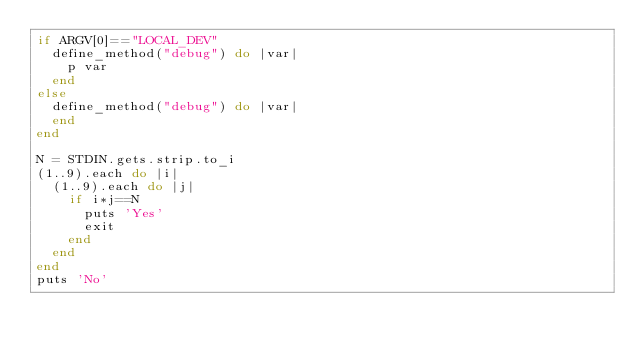<code> <loc_0><loc_0><loc_500><loc_500><_Ruby_>if ARGV[0]=="LOCAL_DEV"
  define_method("debug") do |var|
    p var
  end
else
  define_method("debug") do |var|
  end
end

N = STDIN.gets.strip.to_i
(1..9).each do |i|
  (1..9).each do |j|
    if i*j==N
      puts 'Yes'
      exit
    end
  end
end
puts 'No'</code> 